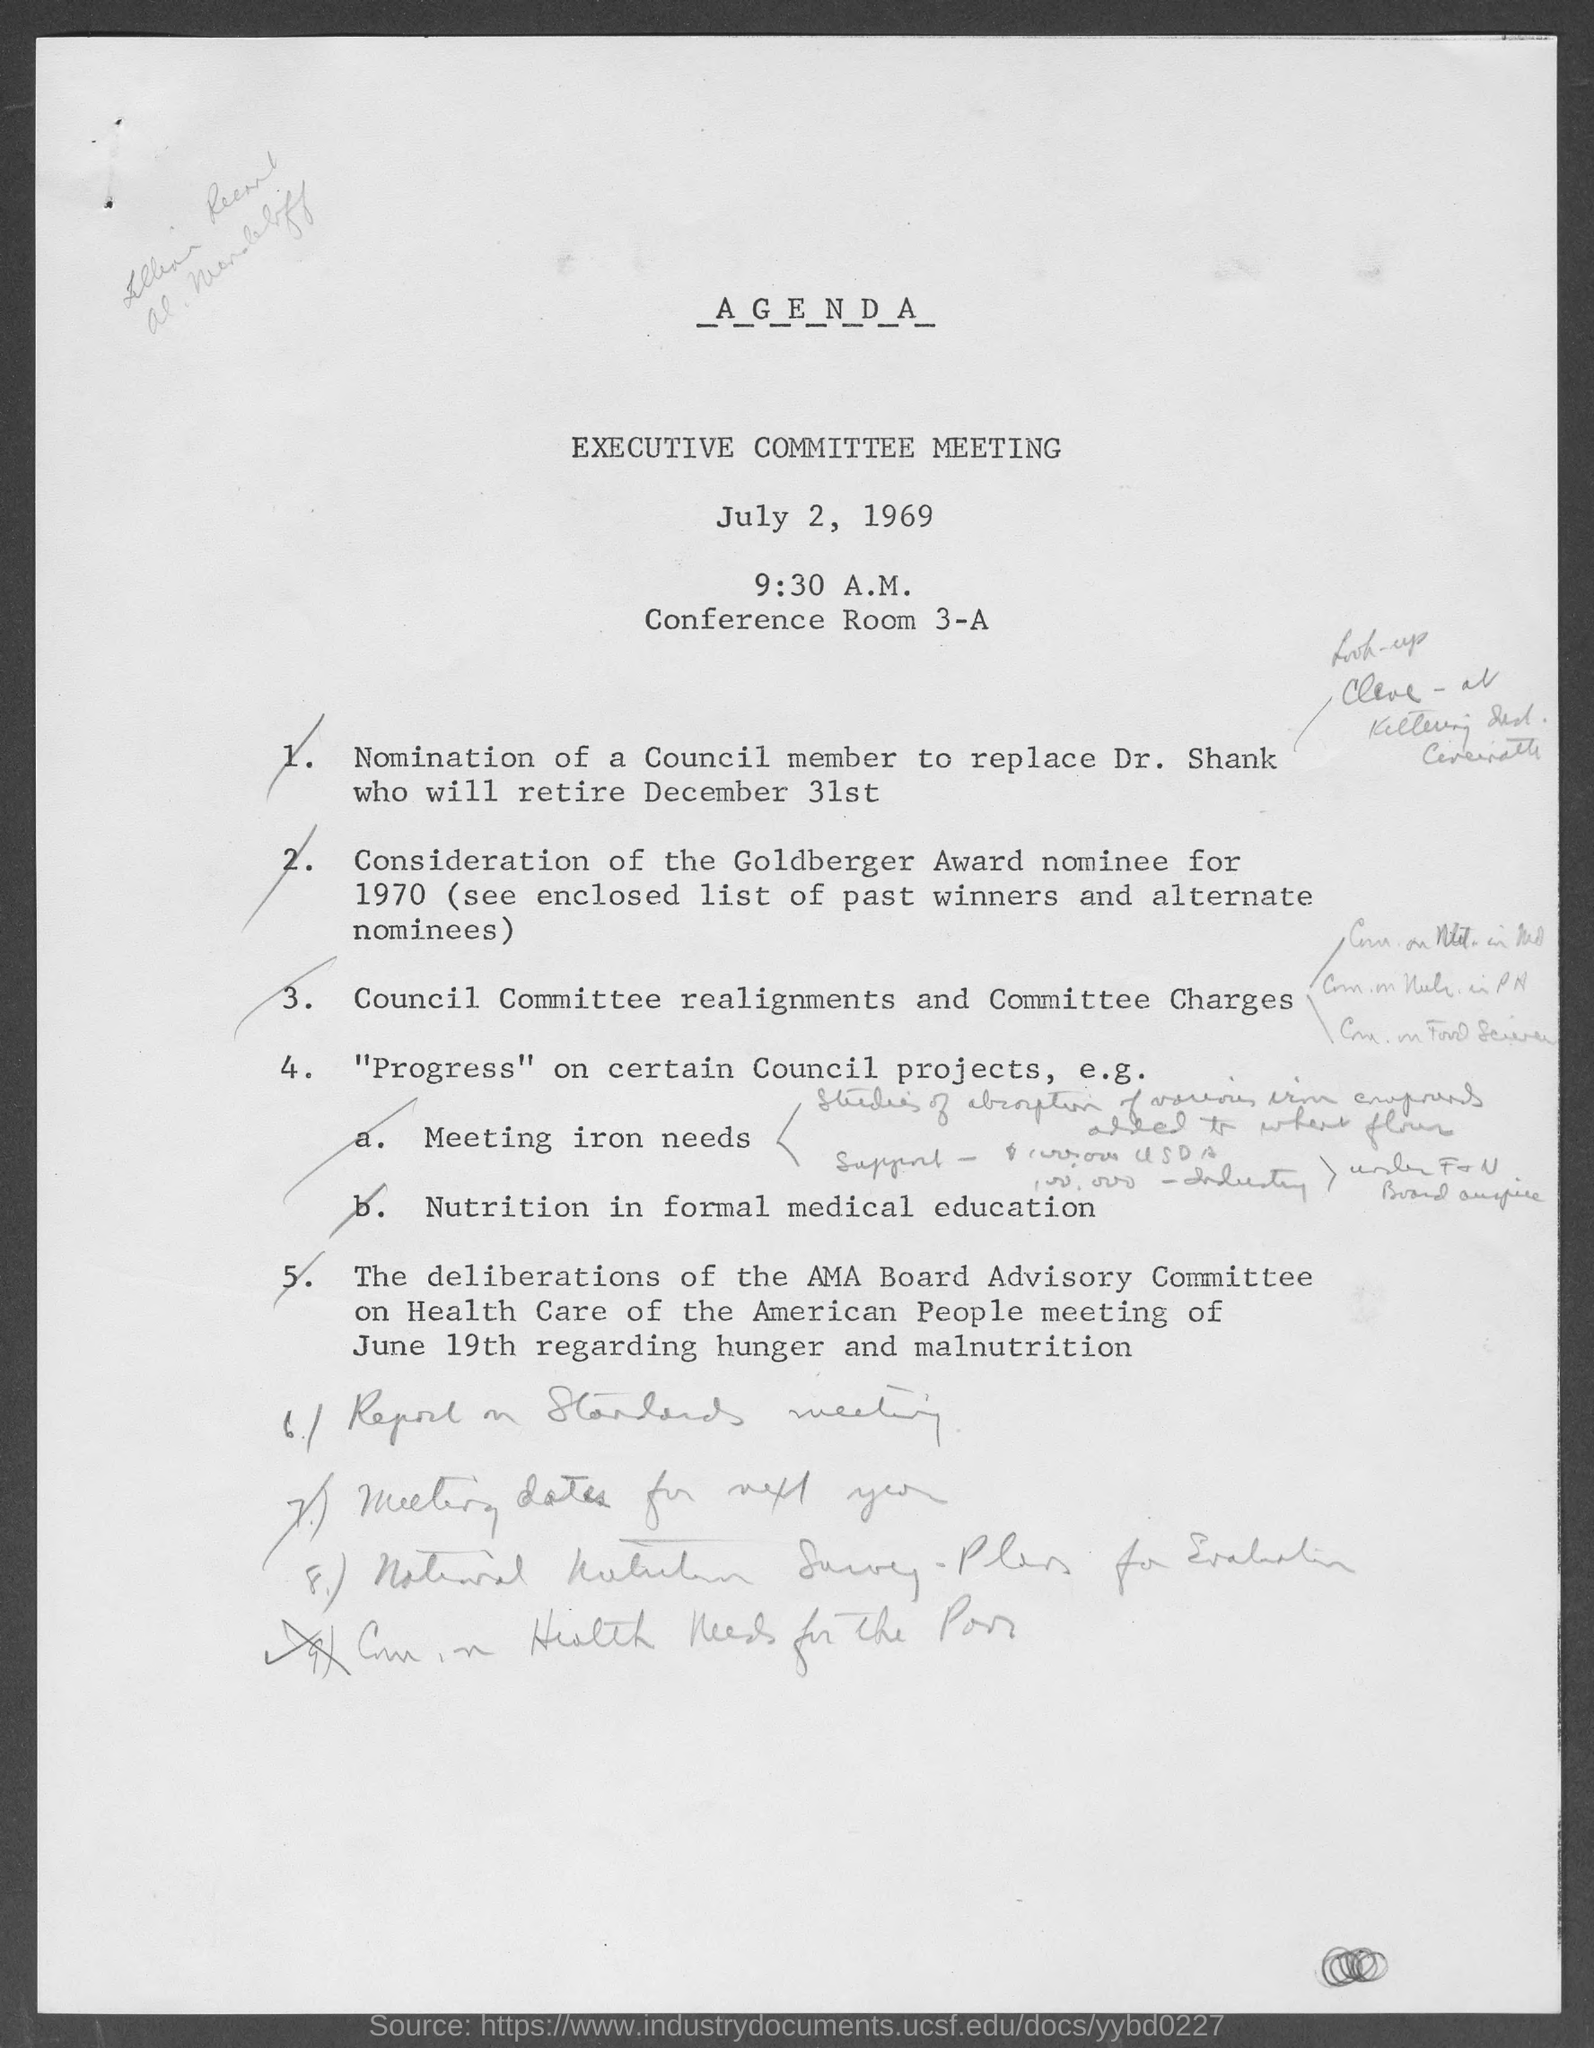List a handful of essential elements in this visual. The meeting was scheduled to start at 9:30 AM. The name of the meeting is the Executive Committee meeting. The meeting was scheduled for July 2, 1969. 